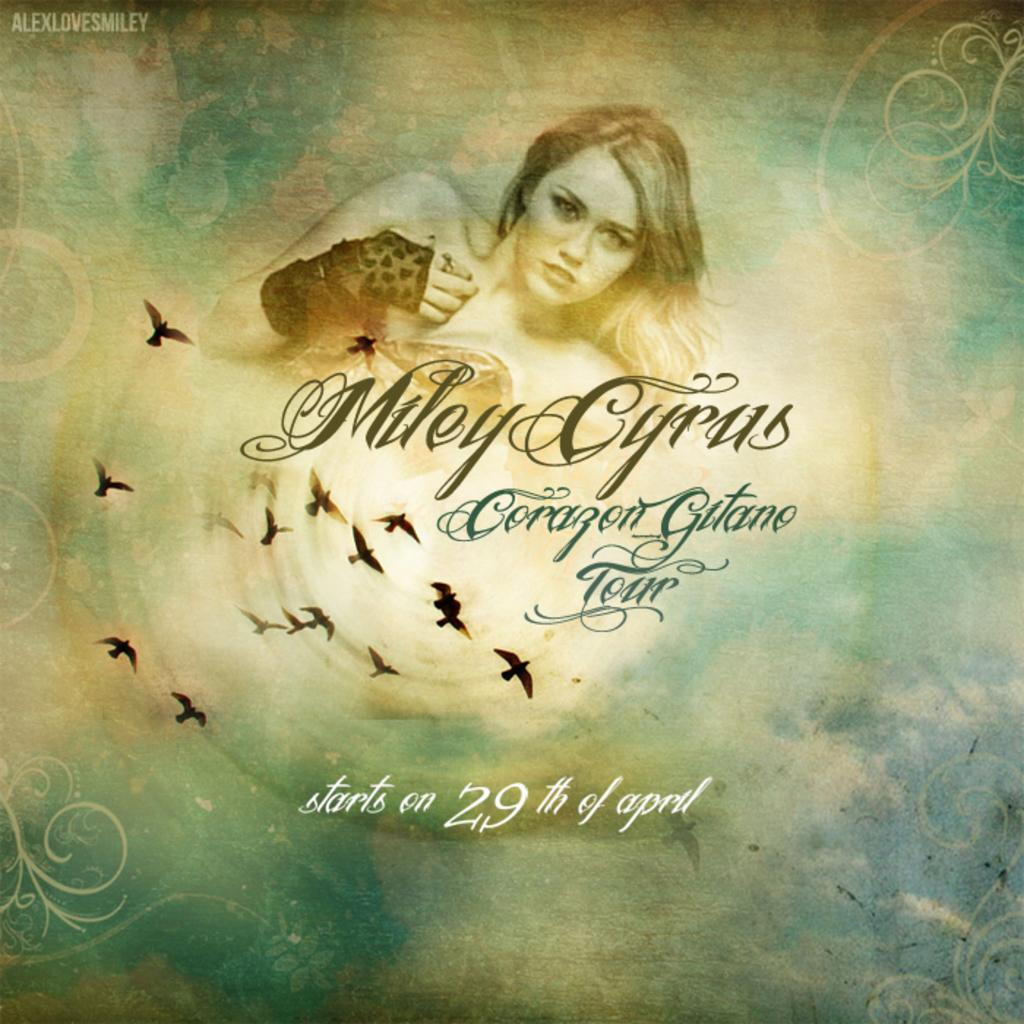<image>
Offer a succinct explanation of the picture presented. A cover of a Miley Cyrus CD with Miley on the cover. 